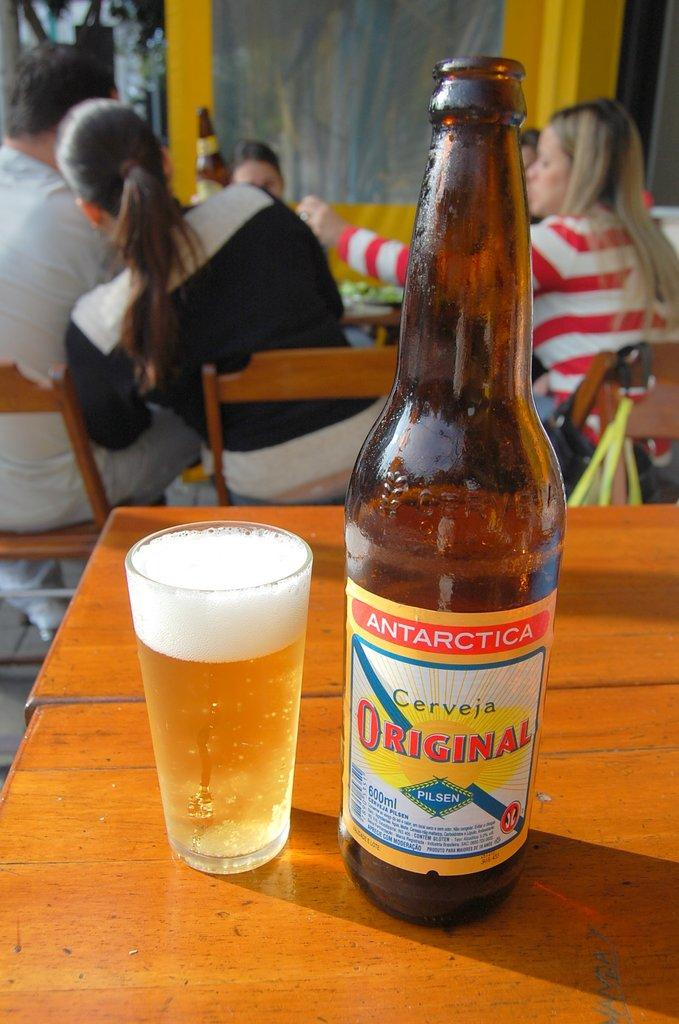Provide a one-sentence caption for the provided image. a glass and bottle of Antarctica Cerveja Original on a restaurant table. 